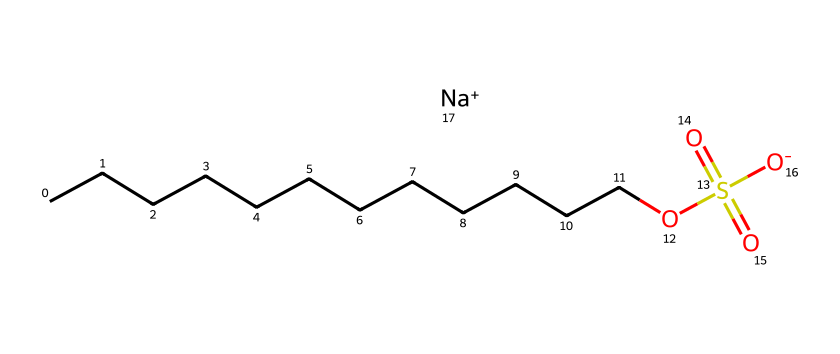What is the molecular formula of sodium lauryl sulfate? To find the molecular formula, count the atoms represented in the SMILES string. The long carbon chain (CCCCCCCCCCCC) indicates 12 carbon (C) atoms, there are 26 hydrogen (H) atoms, one sulfur (S) atom, and four oxygen (O) atoms. Thus, the molecular formula is C12H25NaO4S.
Answer: C12H25NaO4S How many carbon atoms are in sodium lauryl sulfate? The SMILES representation shows a straight chain of twelve carbon (C) atoms denoted by CCCCCCCCCCCC. Thus, there are 12 carbon atoms.
Answer: 12 What functional group is present in sodium lauryl sulfate? The presence of the sulfate group (OS(=O)(=O)[O-]) indicates that sodium lauryl sulfate contains a sulfate functional group.
Answer: sulfate What is the total number of oxygen atoms in sodium lauryl sulfate? By examining the chemical structure, we can see that there are four oxygen (O) atoms, indicated by the sulfate group and the alcohol group in the structure.
Answer: 4 Which element in sodium lauryl sulfate gives it its surfactant properties? The sulfonate (or sulfate) group is responsible for the surfactant properties, allowing the molecule to interact with both water and oils, thus enabling cleaning.
Answer: sulfate What charge does the sodium ion carry in sodium lauryl sulfate? The SMILES notation includes the notation [Na+]. This indicates that the sodium ion carries a positive charge.
Answer: positive Why does sodium lauryl sulfate form micelles in water? Sodium lauryl sulfate has both hydrophobic (non-polar) hydrocarbon tail and hydrophilic (polar) sulfate head. In water, these properties allow the molecules to arrange themselves into structures called micelles, with the tails inward and the heads outward.
Answer: micelles 